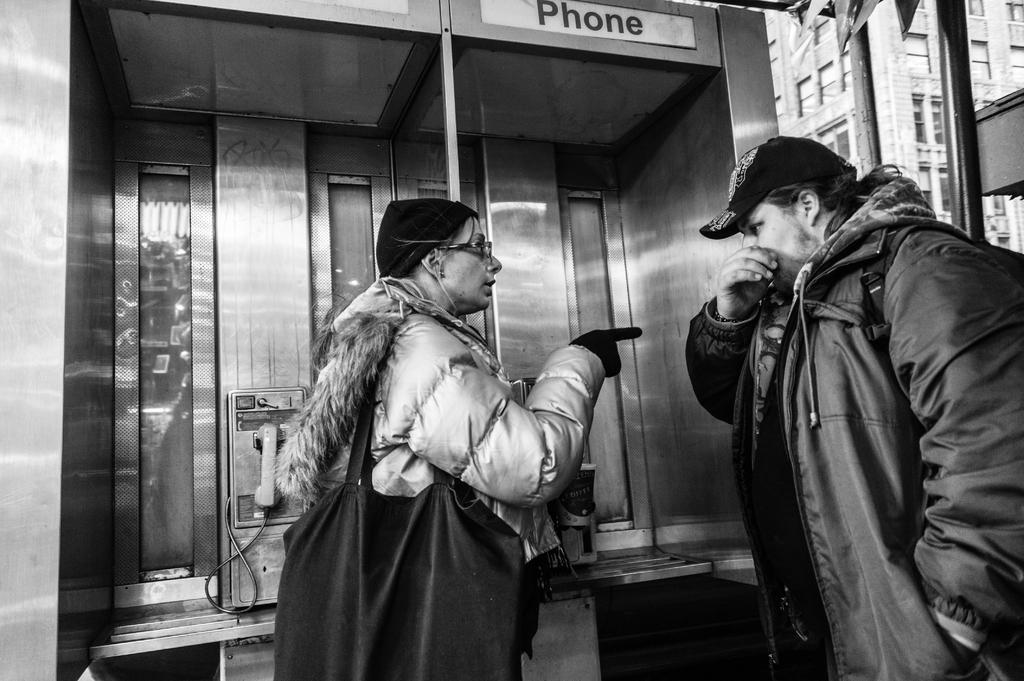Please provide a concise description of this image. This picture shows a woman speaking with a man both of them wore caps on their heads and jackets and we see women wore handbag and gloves to her hands and we see a telephone booth and a building. 